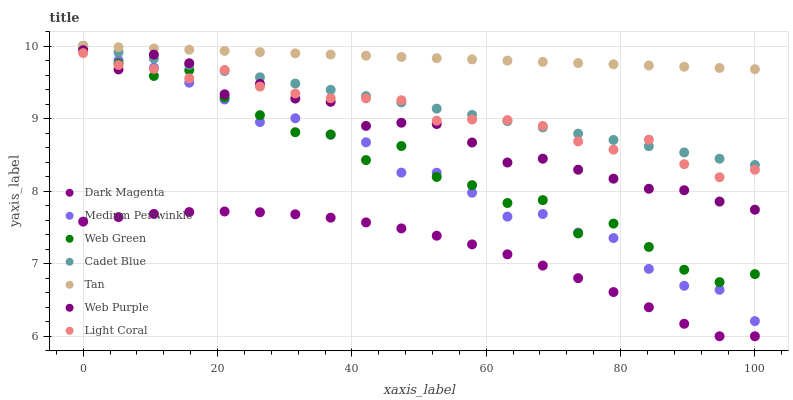Does Dark Magenta have the minimum area under the curve?
Answer yes or no. Yes. Does Tan have the maximum area under the curve?
Answer yes or no. Yes. Does Medium Periwinkle have the minimum area under the curve?
Answer yes or no. No. Does Medium Periwinkle have the maximum area under the curve?
Answer yes or no. No. Is Cadet Blue the smoothest?
Answer yes or no. Yes. Is Web Green the roughest?
Answer yes or no. Yes. Is Dark Magenta the smoothest?
Answer yes or no. No. Is Dark Magenta the roughest?
Answer yes or no. No. Does Dark Magenta have the lowest value?
Answer yes or no. Yes. Does Medium Periwinkle have the lowest value?
Answer yes or no. No. Does Tan have the highest value?
Answer yes or no. Yes. Does Medium Periwinkle have the highest value?
Answer yes or no. No. Is Dark Magenta less than Web Green?
Answer yes or no. Yes. Is Web Green greater than Dark Magenta?
Answer yes or no. Yes. Does Web Purple intersect Web Green?
Answer yes or no. Yes. Is Web Purple less than Web Green?
Answer yes or no. No. Is Web Purple greater than Web Green?
Answer yes or no. No. Does Dark Magenta intersect Web Green?
Answer yes or no. No. 